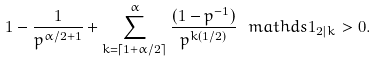Convert formula to latex. <formula><loc_0><loc_0><loc_500><loc_500>1 - \frac { 1 } { p ^ { \alpha / 2 + 1 } } + \sum _ { k = \lceil 1 + \alpha / 2 \rceil } ^ { \alpha } \frac { ( 1 - p ^ { - 1 } ) } { p ^ { k ( 1 / 2 ) } } \, \ m a t h d s { 1 } _ { 2 | k } > 0 .</formula> 